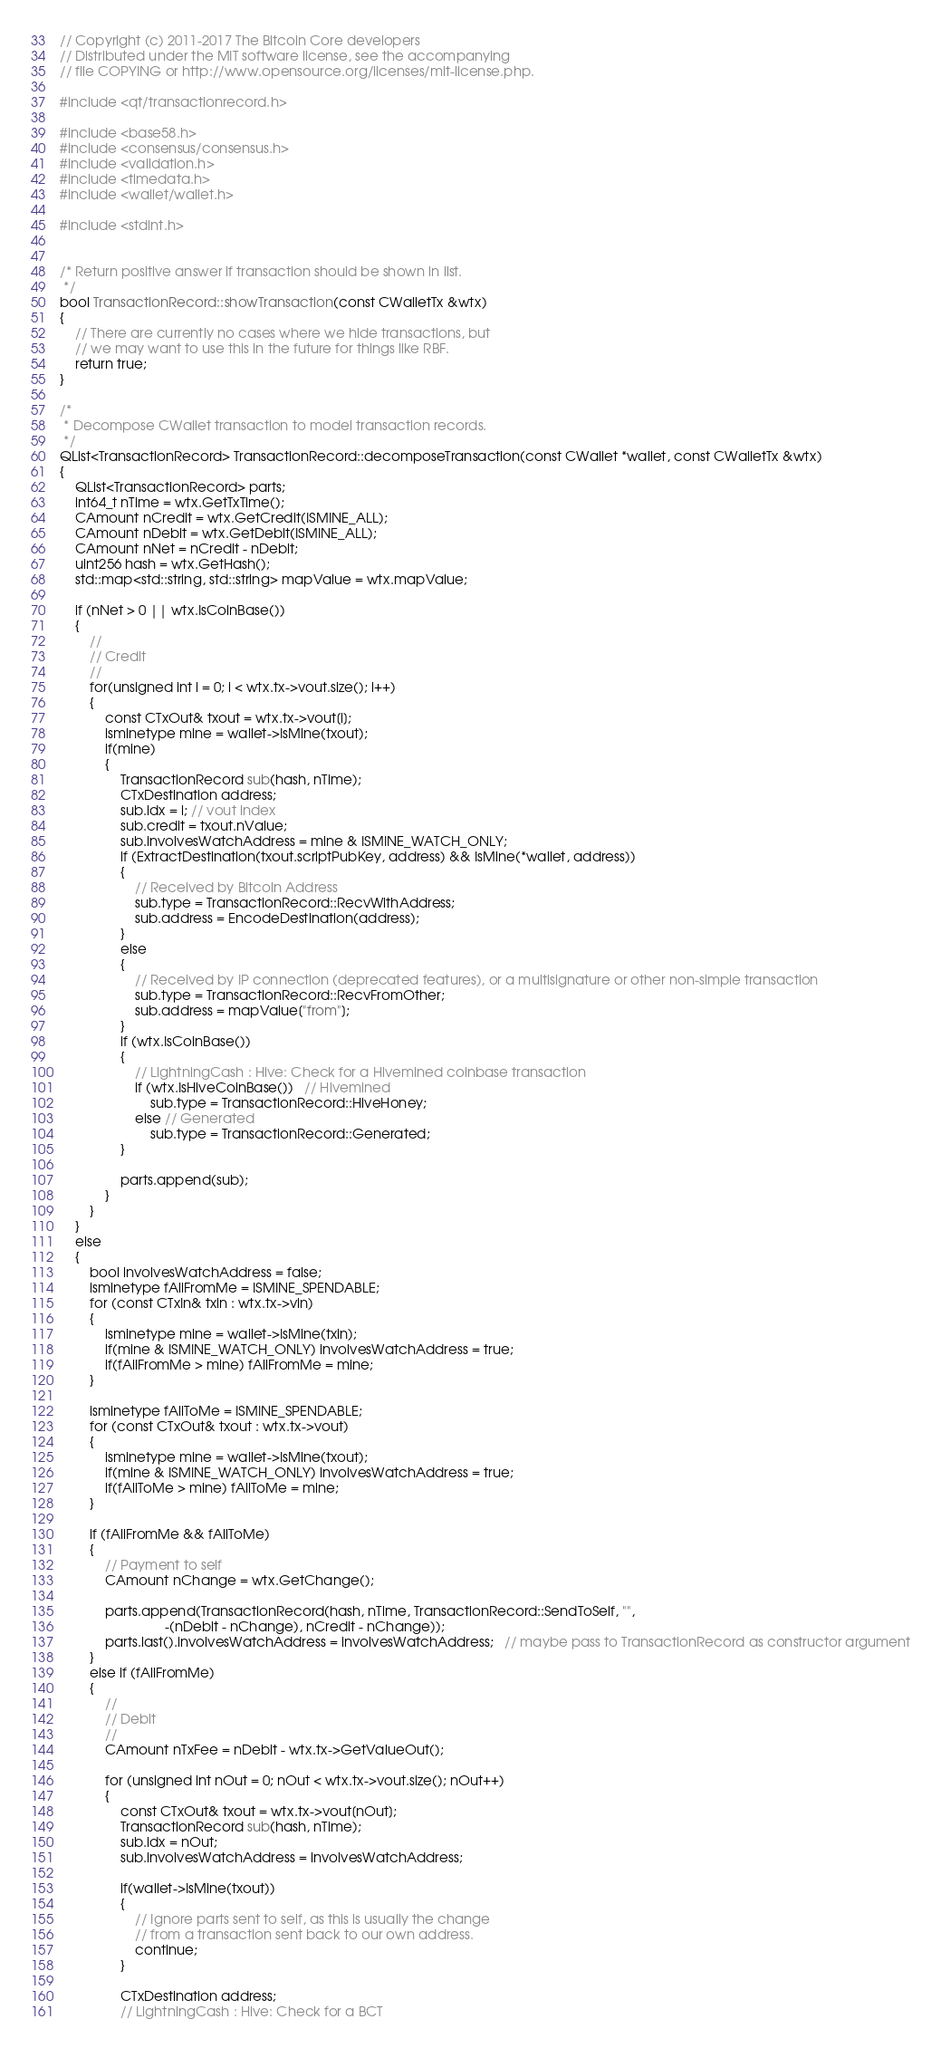Convert code to text. <code><loc_0><loc_0><loc_500><loc_500><_C++_>// Copyright (c) 2011-2017 The Bitcoin Core developers
// Distributed under the MIT software license, see the accompanying
// file COPYING or http://www.opensource.org/licenses/mit-license.php.

#include <qt/transactionrecord.h>

#include <base58.h>
#include <consensus/consensus.h>
#include <validation.h>
#include <timedata.h>
#include <wallet/wallet.h>

#include <stdint.h>


/* Return positive answer if transaction should be shown in list.
 */
bool TransactionRecord::showTransaction(const CWalletTx &wtx)
{
    // There are currently no cases where we hide transactions, but
    // we may want to use this in the future for things like RBF.
    return true;
}

/*
 * Decompose CWallet transaction to model transaction records.
 */
QList<TransactionRecord> TransactionRecord::decomposeTransaction(const CWallet *wallet, const CWalletTx &wtx)
{
    QList<TransactionRecord> parts;
    int64_t nTime = wtx.GetTxTime();
    CAmount nCredit = wtx.GetCredit(ISMINE_ALL);
    CAmount nDebit = wtx.GetDebit(ISMINE_ALL);
    CAmount nNet = nCredit - nDebit;
    uint256 hash = wtx.GetHash();
    std::map<std::string, std::string> mapValue = wtx.mapValue;

    if (nNet > 0 || wtx.IsCoinBase())
    {
        //
        // Credit
        //
        for(unsigned int i = 0; i < wtx.tx->vout.size(); i++)
        {
            const CTxOut& txout = wtx.tx->vout[i];
            isminetype mine = wallet->IsMine(txout);
            if(mine)
            {
                TransactionRecord sub(hash, nTime);
                CTxDestination address;
                sub.idx = i; // vout index
                sub.credit = txout.nValue;
                sub.involvesWatchAddress = mine & ISMINE_WATCH_ONLY;
                if (ExtractDestination(txout.scriptPubKey, address) && IsMine(*wallet, address))
                {
                    // Received by Bitcoin Address
                    sub.type = TransactionRecord::RecvWithAddress;
                    sub.address = EncodeDestination(address);
                }
                else
                {
                    // Received by IP connection (deprecated features), or a multisignature or other non-simple transaction
                    sub.type = TransactionRecord::RecvFromOther;
                    sub.address = mapValue["from"];
                }
                if (wtx.IsCoinBase())
                {
                    // LightningCash : Hive: Check for a Hivemined coinbase transaction
                    if (wtx.IsHiveCoinBase())   // Hivemined
                        sub.type = TransactionRecord::HiveHoney;
                    else // Generated
                        sub.type = TransactionRecord::Generated;
                }

                parts.append(sub);
            }
        }
    }
    else
    {
        bool involvesWatchAddress = false;
        isminetype fAllFromMe = ISMINE_SPENDABLE;
        for (const CTxIn& txin : wtx.tx->vin)
        {
            isminetype mine = wallet->IsMine(txin);
            if(mine & ISMINE_WATCH_ONLY) involvesWatchAddress = true;
            if(fAllFromMe > mine) fAllFromMe = mine;
        }

        isminetype fAllToMe = ISMINE_SPENDABLE;
        for (const CTxOut& txout : wtx.tx->vout)
        {
            isminetype mine = wallet->IsMine(txout);
            if(mine & ISMINE_WATCH_ONLY) involvesWatchAddress = true;
            if(fAllToMe > mine) fAllToMe = mine;
        }

        if (fAllFromMe && fAllToMe)
        {
            // Payment to self
            CAmount nChange = wtx.GetChange();

            parts.append(TransactionRecord(hash, nTime, TransactionRecord::SendToSelf, "",
                            -(nDebit - nChange), nCredit - nChange));
            parts.last().involvesWatchAddress = involvesWatchAddress;   // maybe pass to TransactionRecord as constructor argument
        }
        else if (fAllFromMe)
        {
            //
            // Debit
            //
            CAmount nTxFee = nDebit - wtx.tx->GetValueOut();

            for (unsigned int nOut = 0; nOut < wtx.tx->vout.size(); nOut++)
            {
                const CTxOut& txout = wtx.tx->vout[nOut];
                TransactionRecord sub(hash, nTime);
                sub.idx = nOut;
                sub.involvesWatchAddress = involvesWatchAddress;

                if(wallet->IsMine(txout))
                {
                    // Ignore parts sent to self, as this is usually the change
                    // from a transaction sent back to our own address.
                    continue;
                }

                CTxDestination address;
                // LightningCash : Hive: Check for a BCT</code> 